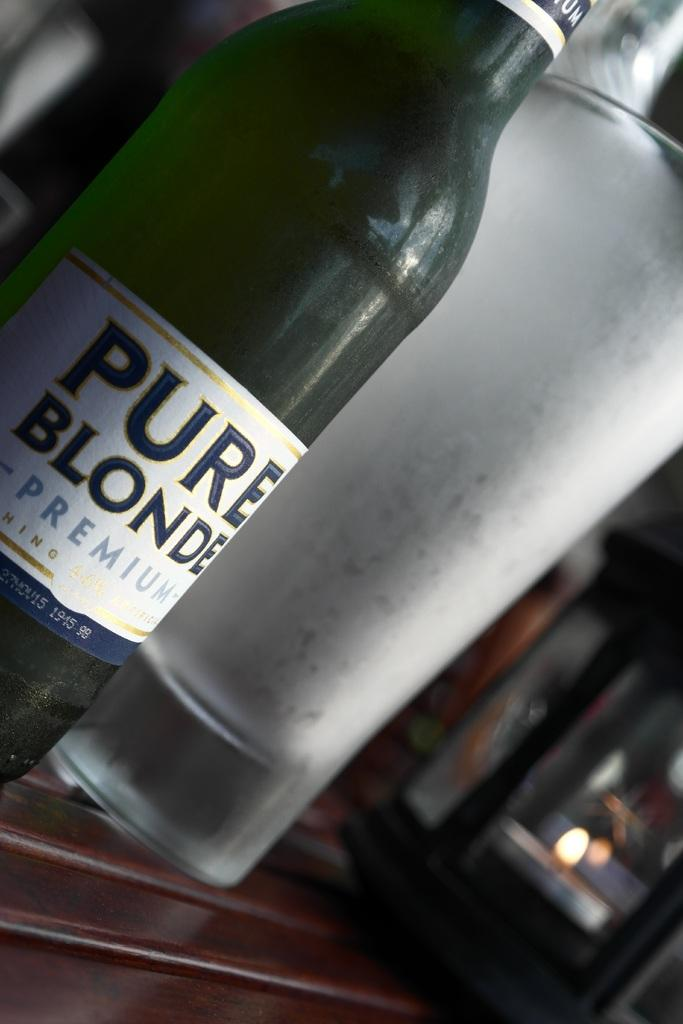<image>
Write a terse but informative summary of the picture. A bottle of Pure Blonde Premium on a table beside a glass. 